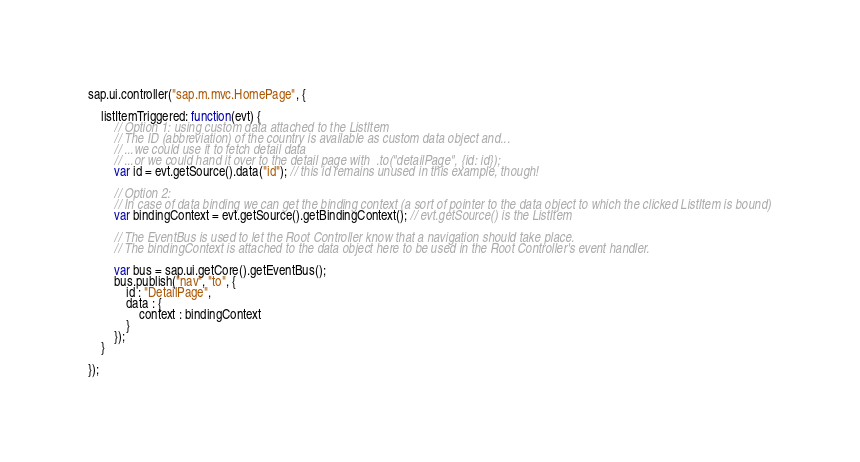<code> <loc_0><loc_0><loc_500><loc_500><_JavaScript_>sap.ui.controller("sap.m.mvc.HomePage", {

	listItemTriggered: function(evt) {
		// Option 1: using custom data attached to the ListItem
		// The ID (abbreviation) of the country is available as custom data object and...
		// ...we could use it to fetch detail data
		// ...or we could hand it over to the detail page with  .to("detailPage", {id: id});
		var id = evt.getSource().data("id"); // this id remains unused in this example, though!

		// Option 2:
		// In case of data binding we can get the binding context (a sort of pointer to the data object to which the clicked ListItem is bound)
		var bindingContext = evt.getSource().getBindingContext(); // evt.getSource() is the ListItem

		// The EventBus is used to let the Root Controller know that a navigation should take place.
		// The bindingContext is attached to the data object here to be used in the Root Controller's event handler.

		var bus = sap.ui.getCore().getEventBus();
		bus.publish("nav", "to", {
			id : "DetailPage",
			data : {
				context : bindingContext
			}
		});
	}

});</code> 